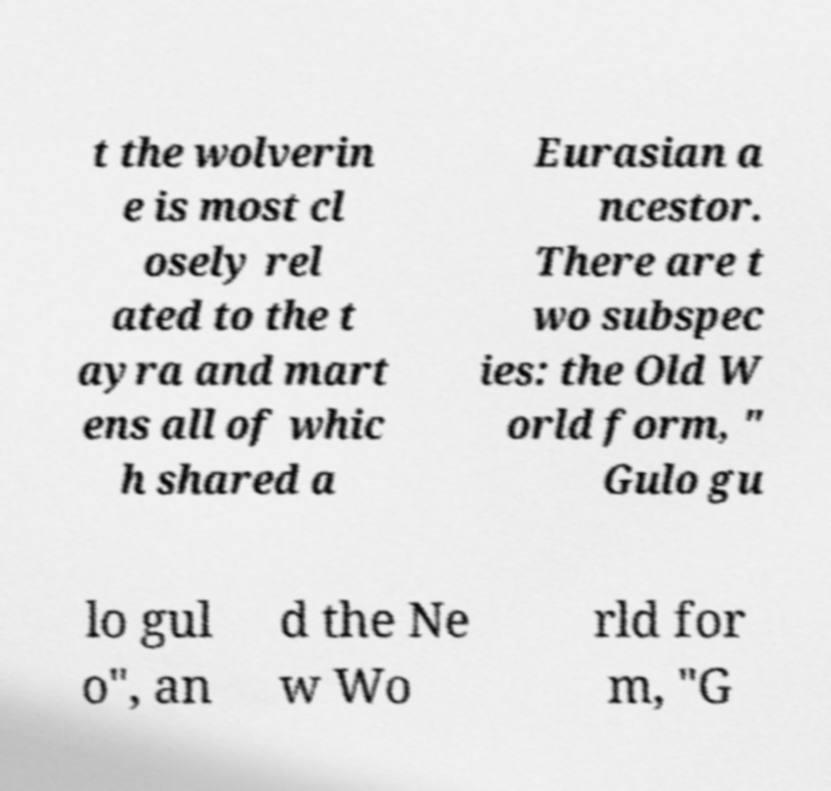Please identify and transcribe the text found in this image. t the wolverin e is most cl osely rel ated to the t ayra and mart ens all of whic h shared a Eurasian a ncestor. There are t wo subspec ies: the Old W orld form, " Gulo gu lo gul o", an d the Ne w Wo rld for m, "G 